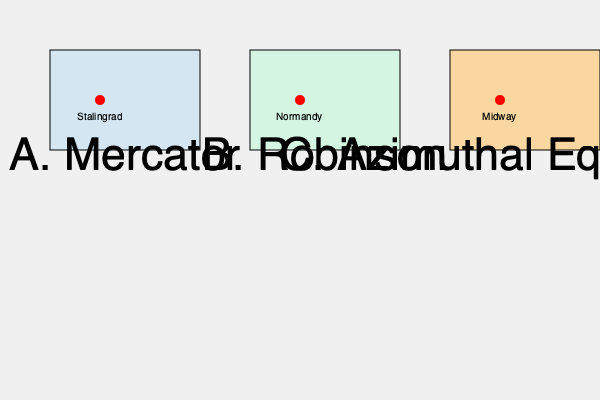Which map projection would be most appropriate for accurately representing the relative distances between the major World War II battle locations of Stalingrad, Normandy, and Midway, while minimizing distortion across different regions of the globe? To determine the most appropriate map projection for representing World War II battle locations, we need to consider the following factors:

1. Global coverage: The battles occurred across different continents and oceans.
2. Distance accuracy: We need to maintain relative distances between locations.
3. Minimal distortion: The projection should minimize distortion across various regions.

Let's analyze each projection:

A. Mercator Projection:
   - Preserves angles but severely distorts area and distance, especially near the poles.
   - Not suitable for comparing distances across different latitudes.

B. Robinson Projection:
   - A compromise projection that reduces distortion of area, shape, and distance.
   - Provides a good balance for global views but doesn't preserve exact distances.

C. Azimuthal Equidistant Projection:
   - Maintains accurate distances and directions from the center point to all other points.
   - Ideal for showing relative distances between multiple points across the globe.

For representing Stalingrad (Eastern Europe), Normandy (Western Europe), and Midway (Pacific Ocean), we need a projection that can accurately show distances across these diverse locations.

The Azimuthal Equidistant projection is the best choice because:
1. It preserves true distances from the center point to all other points on the map.
2. It can be centered on a point that minimizes distortion for all three battle locations.
3. It allows for accurate comparison of distances between these globally dispersed locations.

This projection would enable students to visualize and understand the vast scale of World War II operations, reinforcing the global nature of the conflict and the logistical challenges faced by military forces.
Answer: Azimuthal Equidistant Projection 